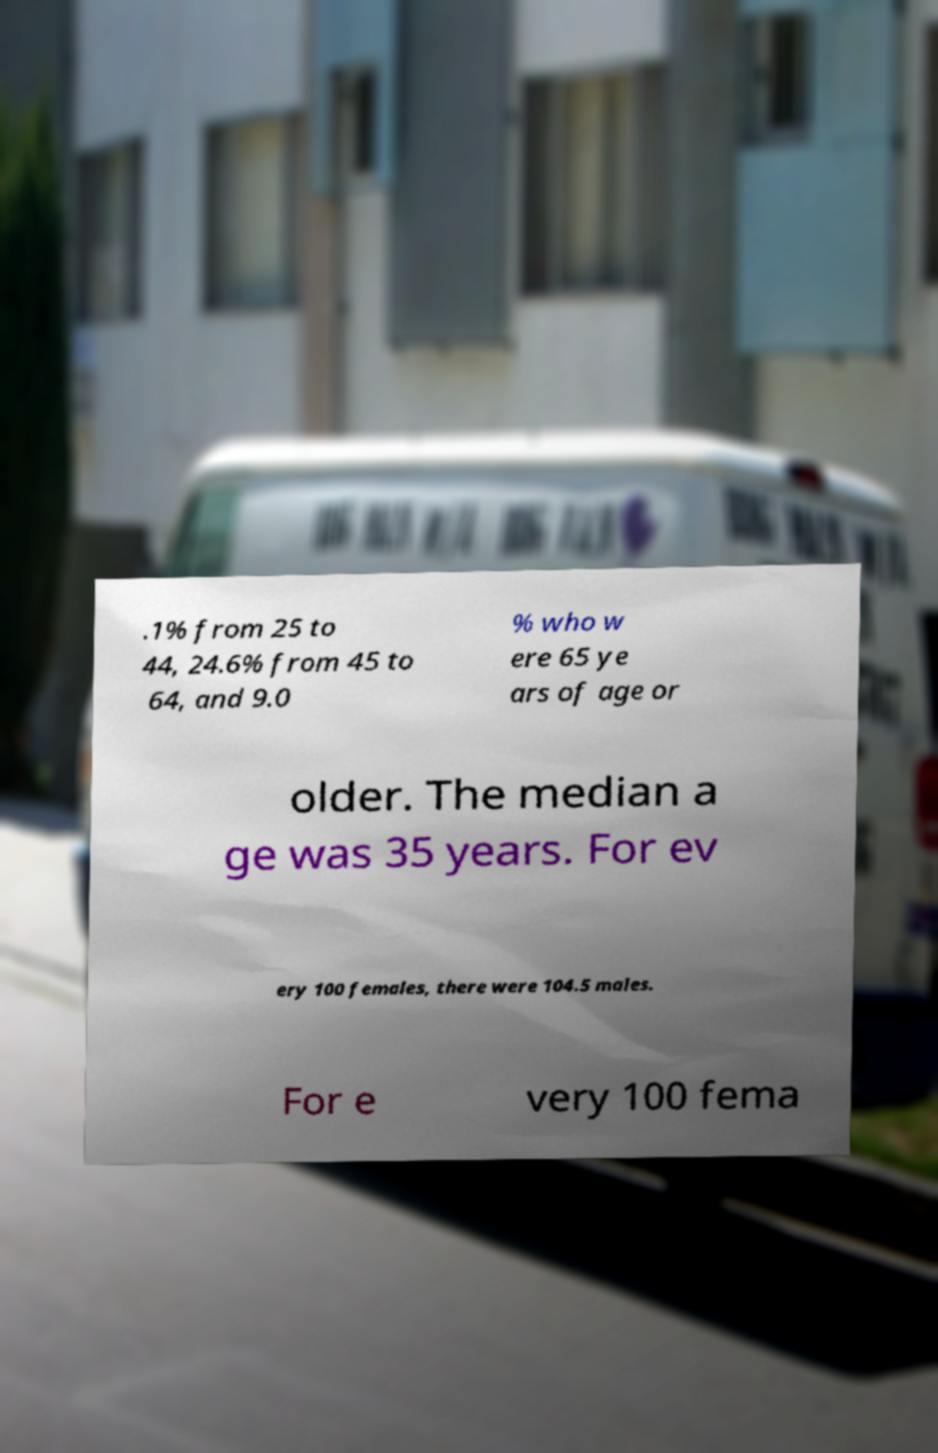Could you assist in decoding the text presented in this image and type it out clearly? .1% from 25 to 44, 24.6% from 45 to 64, and 9.0 % who w ere 65 ye ars of age or older. The median a ge was 35 years. For ev ery 100 females, there were 104.5 males. For e very 100 fema 